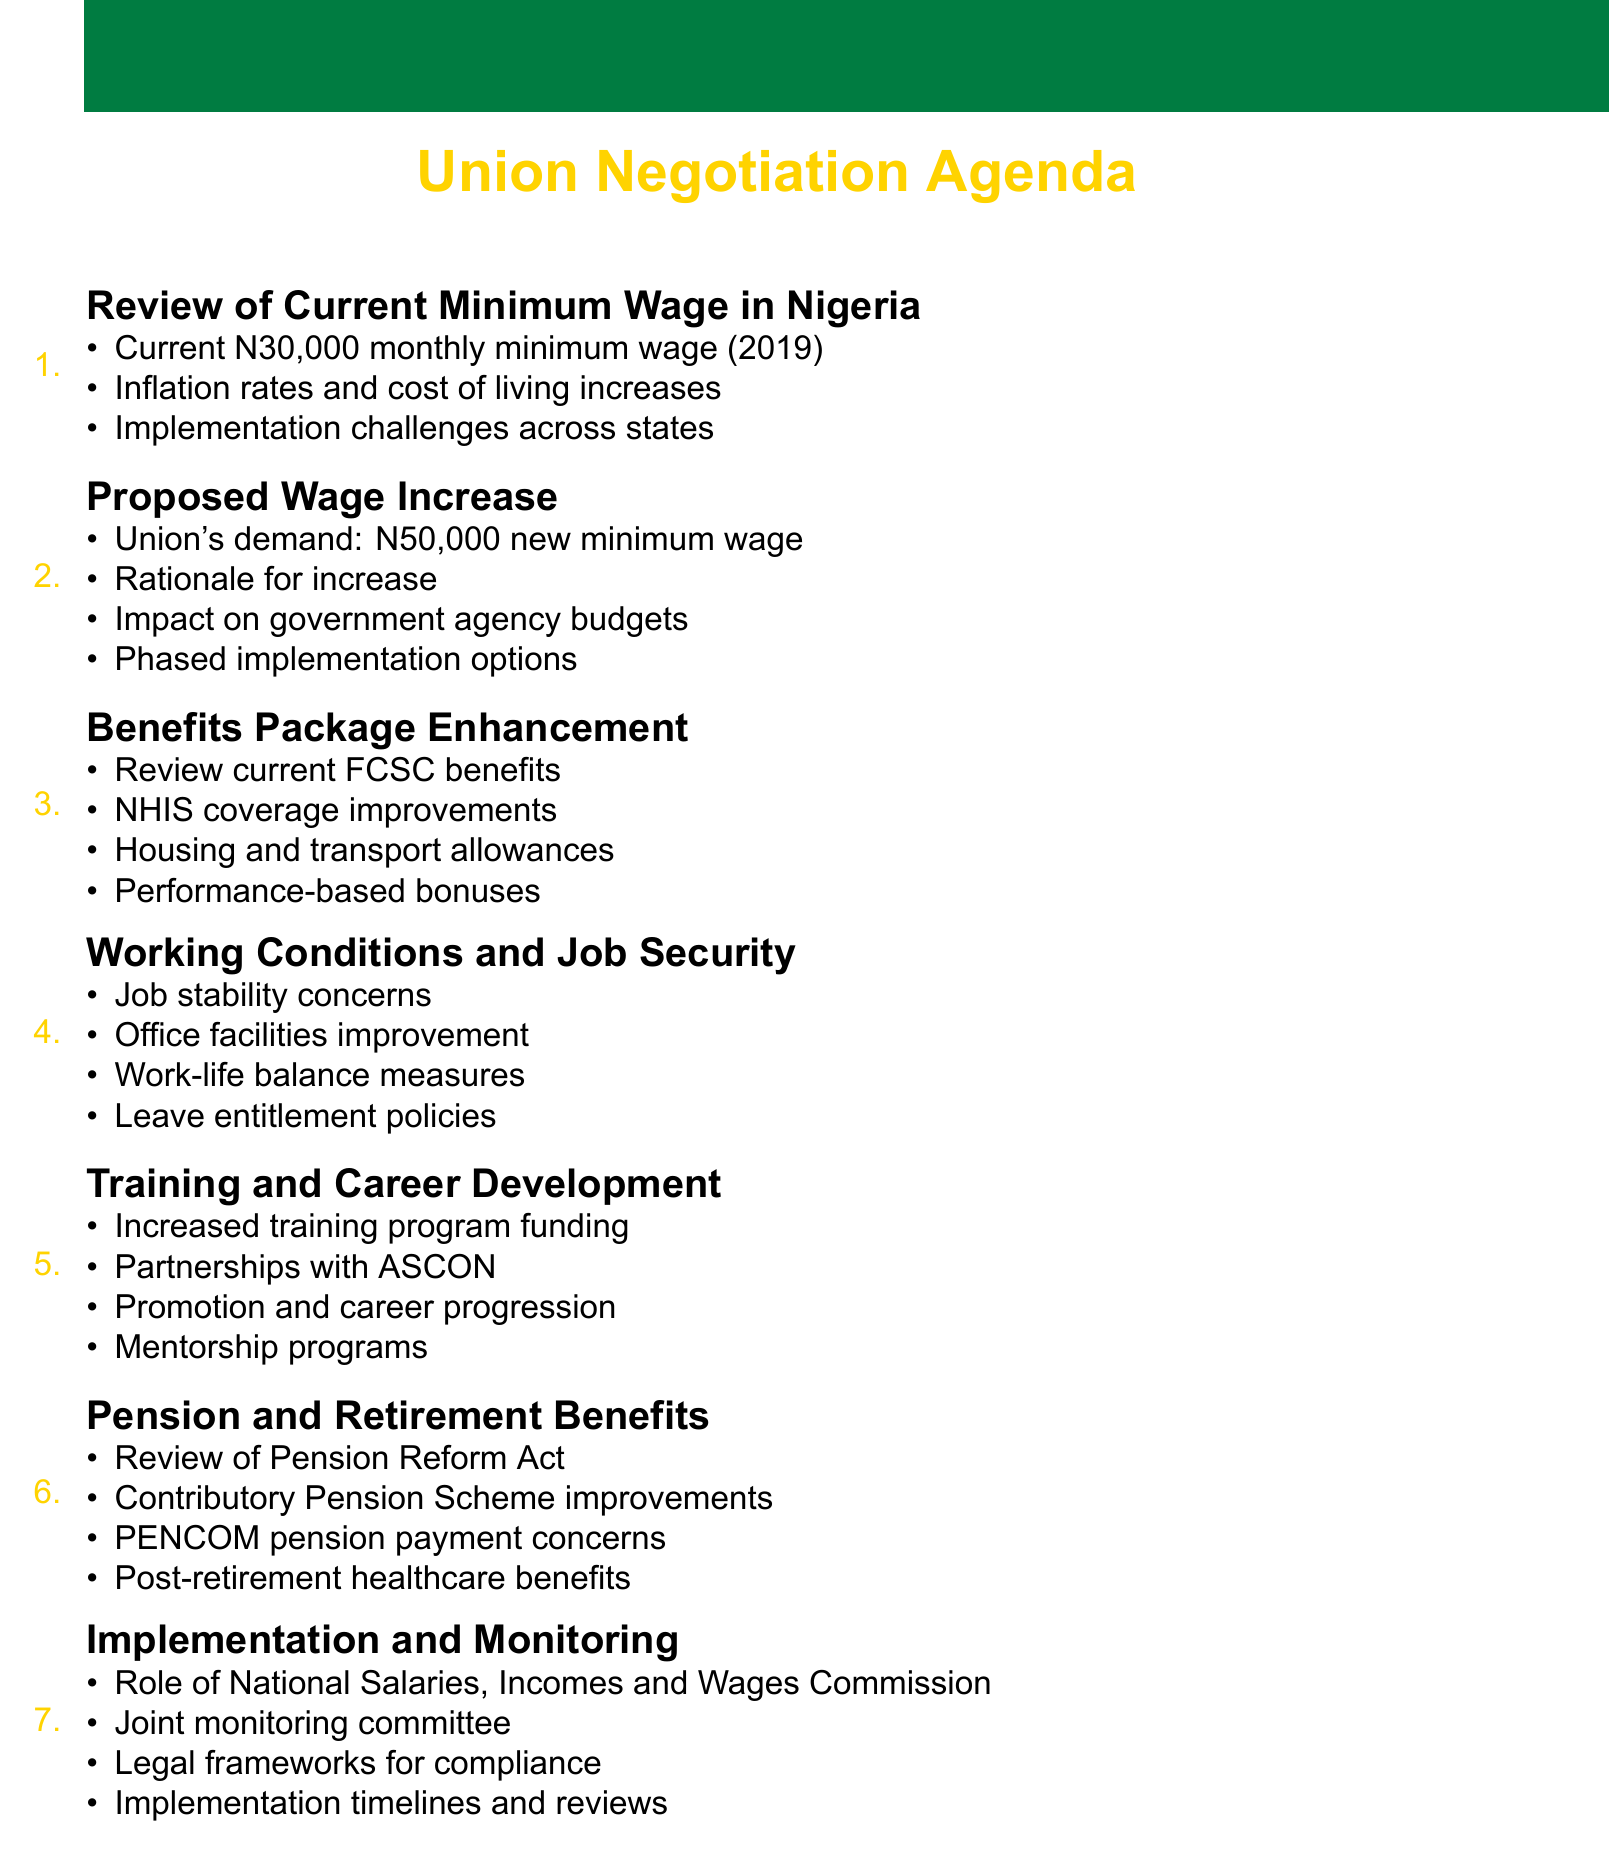What is the current minimum wage in Nigeria? The document states that the current minimum wage is N30,000.
Answer: N30,000 What is the proposed new minimum wage by the union? The agenda outlines a demand for a new minimum wage of N50,000.
Answer: N50,000 What are the proposed improvements to the National Health Insurance Scheme? The agenda item includes proposing improvements to NHIS coverage.
Answer: NHIS coverage improvements What are the concerns regarding job stability related to? The document refers to concerns about job stability in light of government restructuring.
Answer: Government restructuring Which commission's role is discussed in the implementation and monitoring section? The agenda addresses the role of the National Salaries, Incomes and Wages Commission.
Answer: National Salaries, Incomes and Wages Commission What is a proposed employment benefit mentioned in relation to housing? The agenda suggests discussing potential increases in housing allowances.
Answer: Housing allowances What type of programs are proposed to enhance career development? The document proposes introducing mentorship programs within government agencies.
Answer: Mentorship programs What is one of the concerns regarding pensions? The agenda discusses concerns about timely payment of pensions by PENCOM.
Answer: Timely payment of pensions by PENCOM 